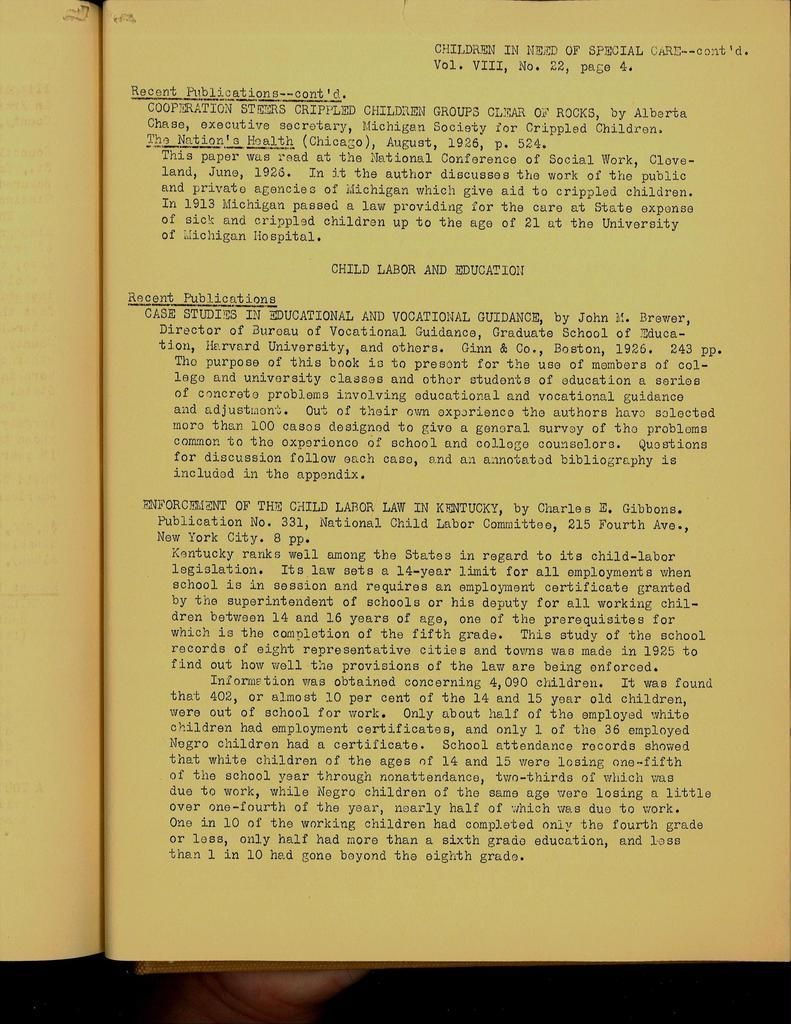<image>
Present a compact description of the photo's key features. open book with yellowing pages with title at top children in need of special care 